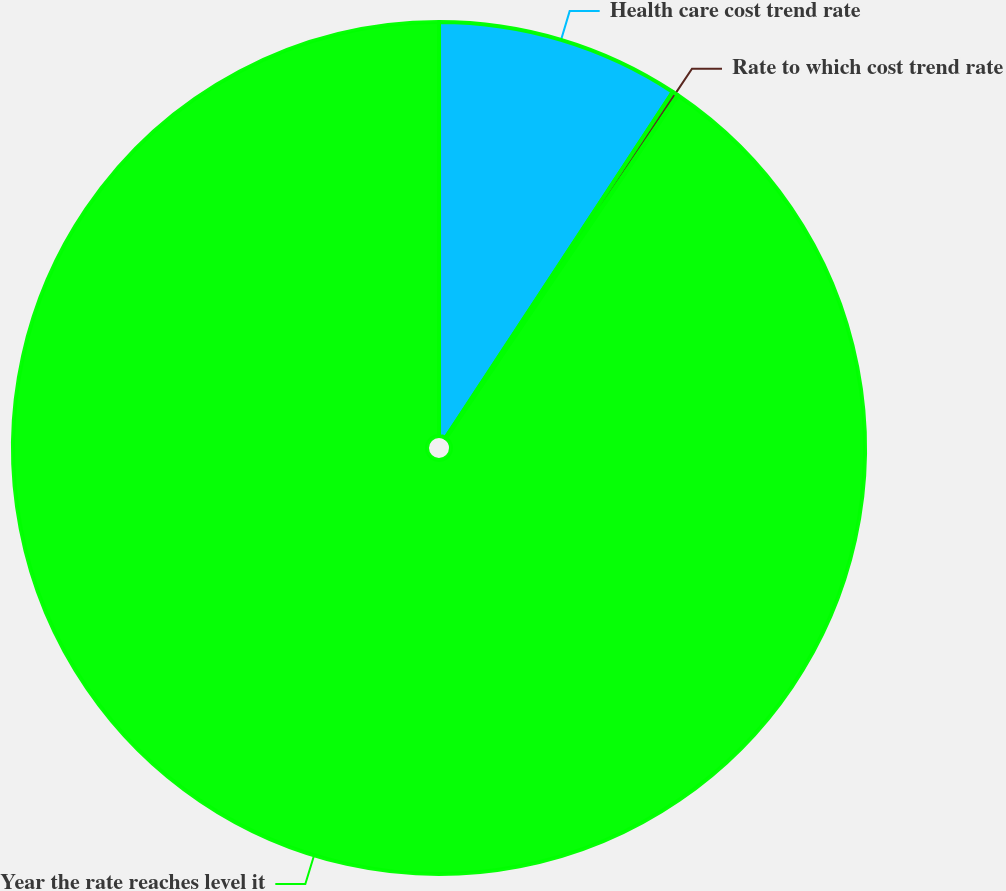Convert chart to OTSL. <chart><loc_0><loc_0><loc_500><loc_500><pie_chart><fcel>Health care cost trend rate<fcel>Rate to which cost trend rate<fcel>Year the rate reaches level it<nl><fcel>9.25%<fcel>0.22%<fcel>90.52%<nl></chart> 